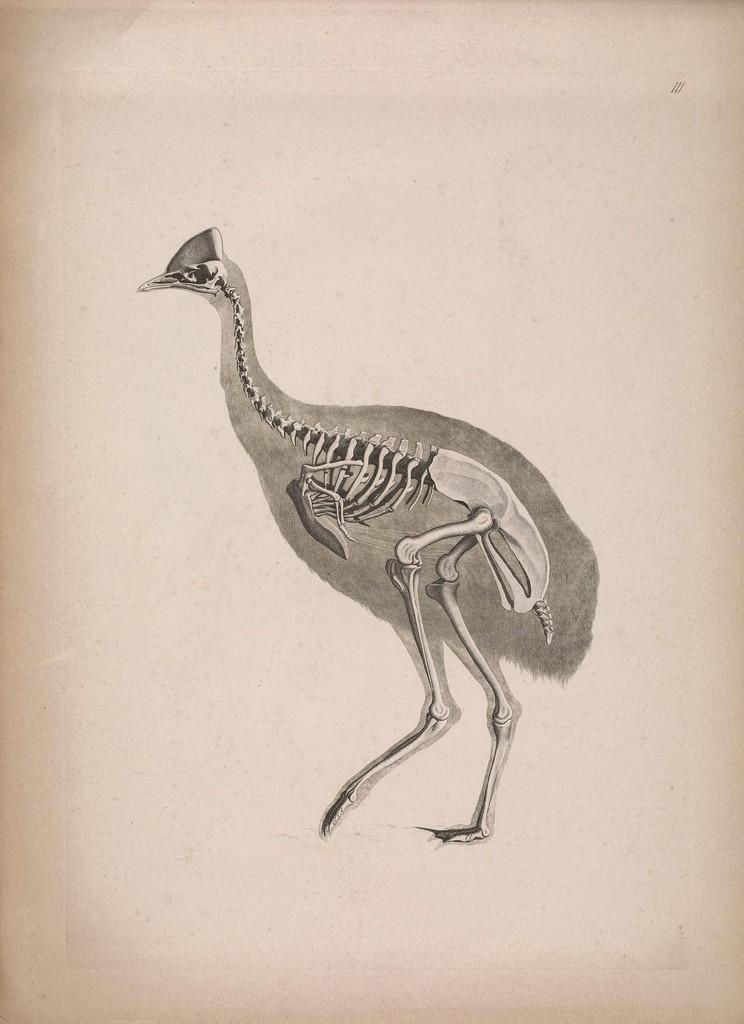What is the main subject in the foreground of the image? There is a skeleton of a bird in the foreground of the image. How many houses are visible in the image? There are no houses visible in the image; it features a skeleton of a bird in the foreground. What type of stove is being used by the grandmother in the image? There is no stove or grandmother present in the image; it features a skeleton of a bird in the foreground. 